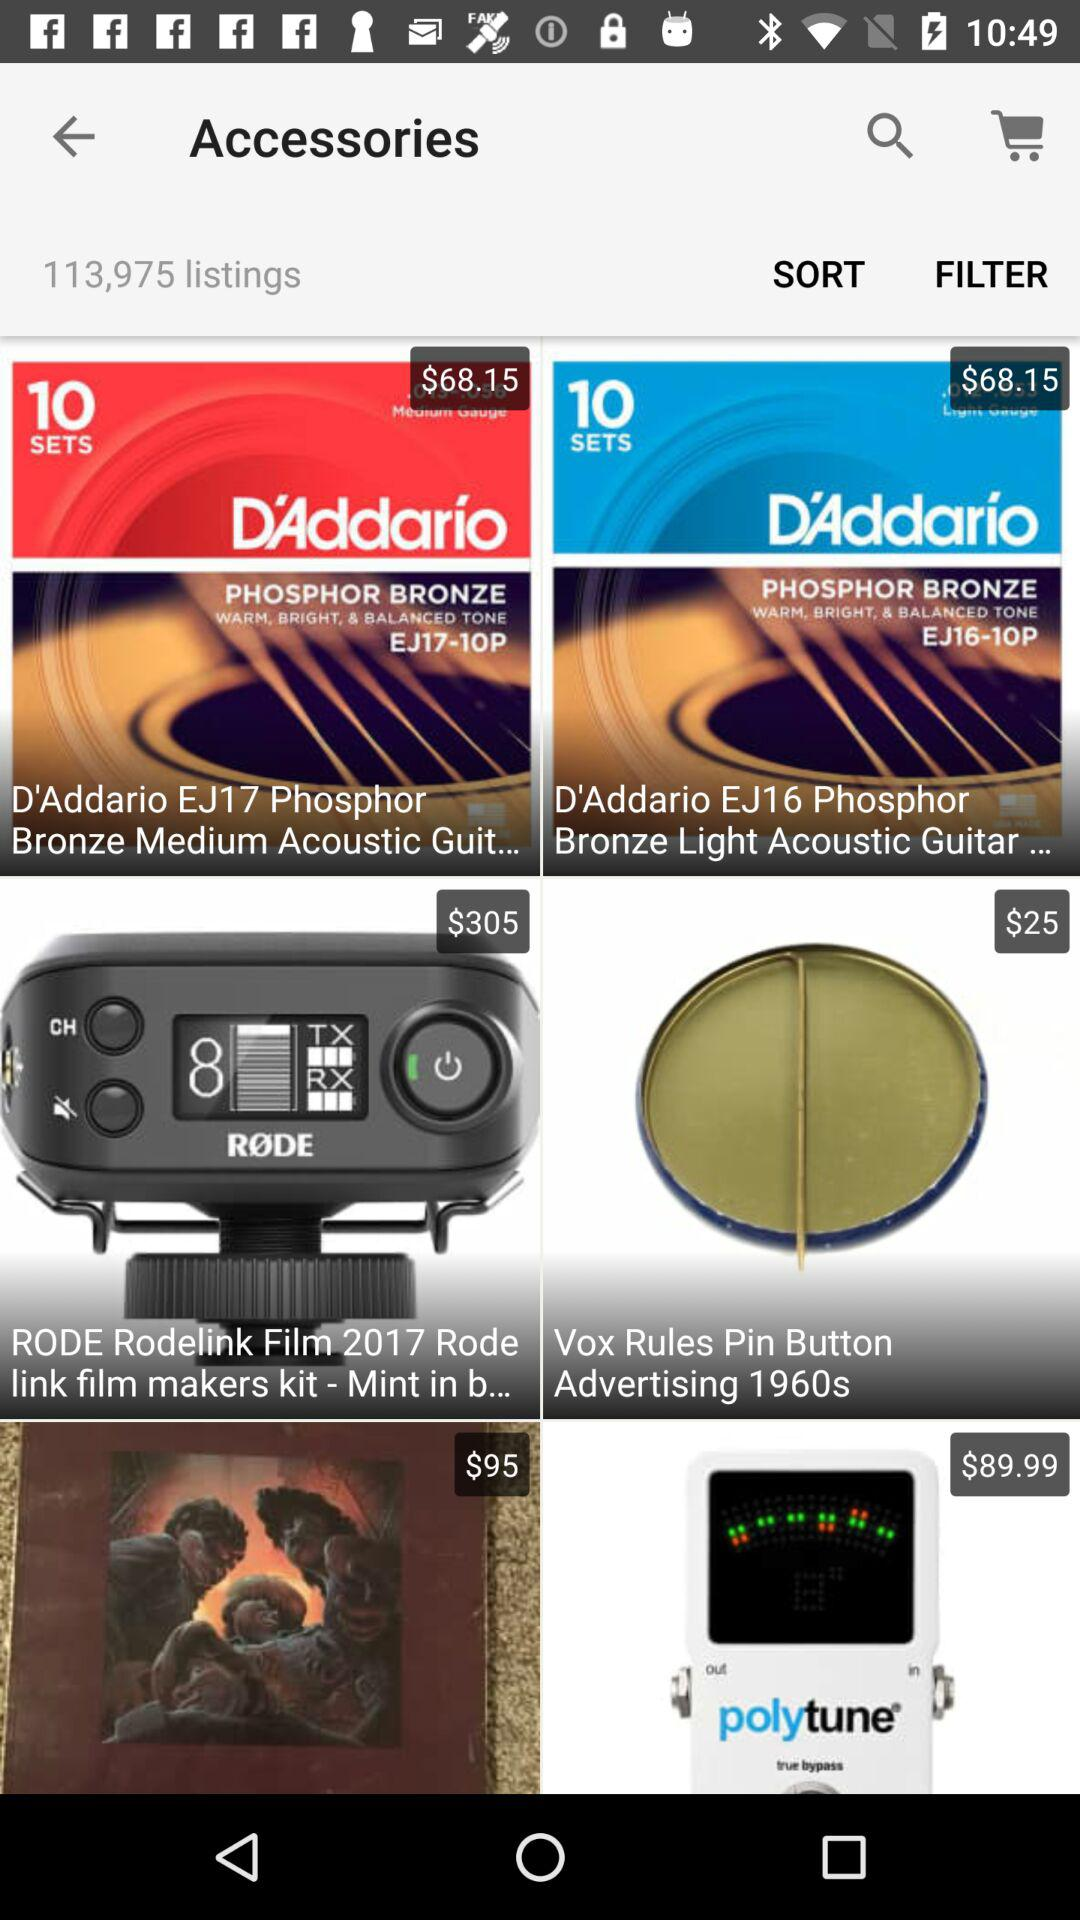What is the price of "D'Addario EJ17 Phosphor Bronze Medium Acoustic Guit..."? The price of "D'Addario EJ17 Phosphor Bronze Medium Acoustic Guit..." is $68.15. 